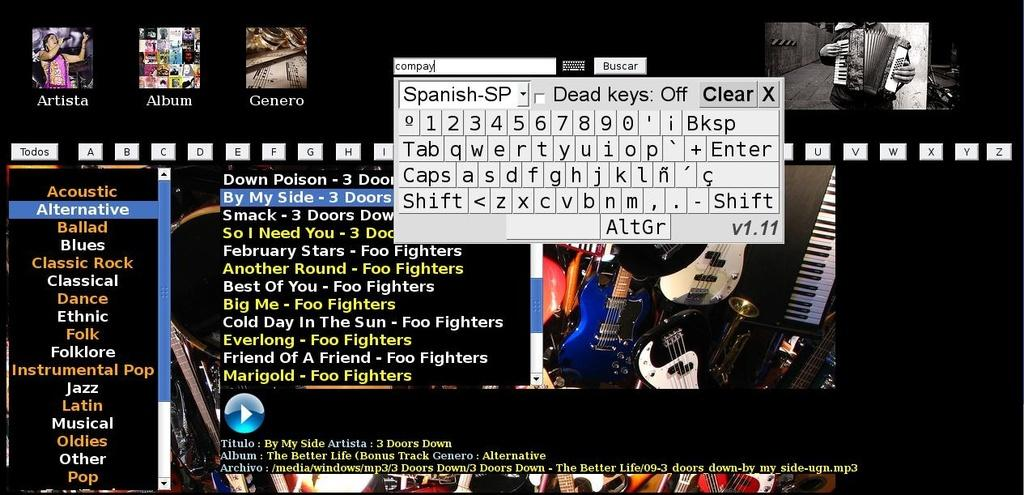What type of image is being described? The image is a screenshot of text. What can be seen in the middle of the image? There is a keyboard in the middle of the image. What is located at the bottom of the image? There are icons at the bottom of the image. What is the primary content of the image? There is text visible in the image. What type of lettuce is being used as a tablecloth in the image? There is no lettuce or tablecloth present in the image; it is a screenshot of text with a keyboard and icons. How many rings are visible on the fingers of the person typing in the image? There is no person typing in the image, as it is a screenshot of text with a keyboard and icons. 